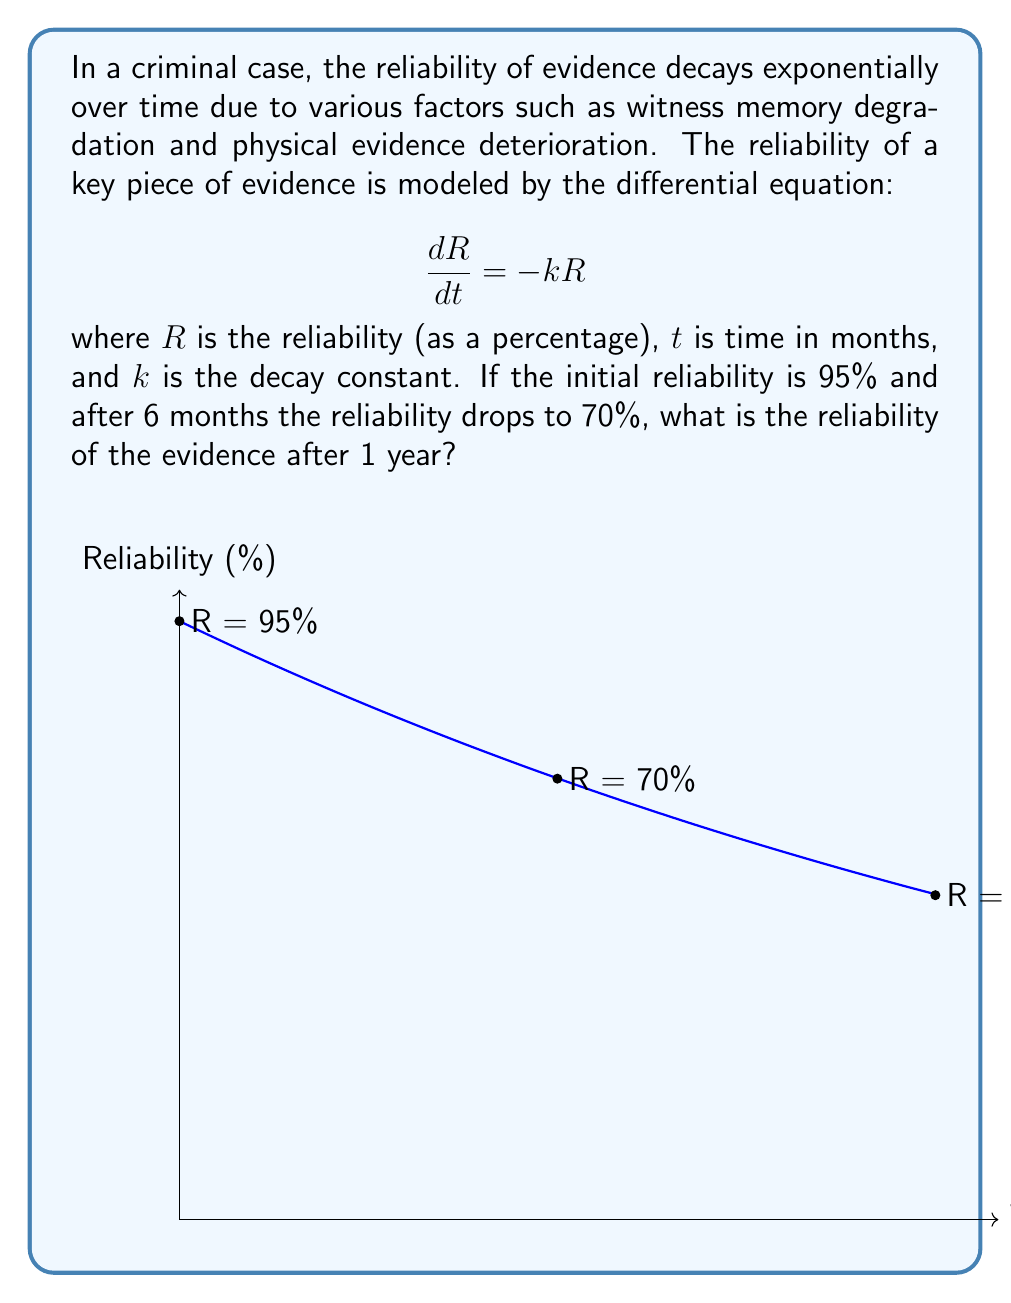Teach me how to tackle this problem. Let's approach this step-by-step:

1) We're given the differential equation: $$\frac{dR}{dt} = -kR$$

2) The solution to this equation is: $$R(t) = R_0e^{-kt}$$
   where $R_0$ is the initial reliability.

3) We know that:
   - Initially (t = 0), R = 95%
   - After 6 months (t = 6), R = 70%

4) Let's use these conditions to find k:
   $$70 = 95e^{-6k}$$

5) Solving for k:
   $$\ln(\frac{70}{95}) = -6k$$
   $$k = -\frac{1}{6}\ln(\frac{70}{95}) \approx 0.0508$$

6) Now that we have k, we can use the equation to find R after 12 months:
   $$R(12) = 95e^{-0.0508 * 12}$$

7) Calculating this:
   $$R(12) = 95e^{-0.6096} \approx 51.67$$

Therefore, after 1 year (12 months), the reliability of the evidence is approximately 51.67%.
Answer: $51.67\%$ 